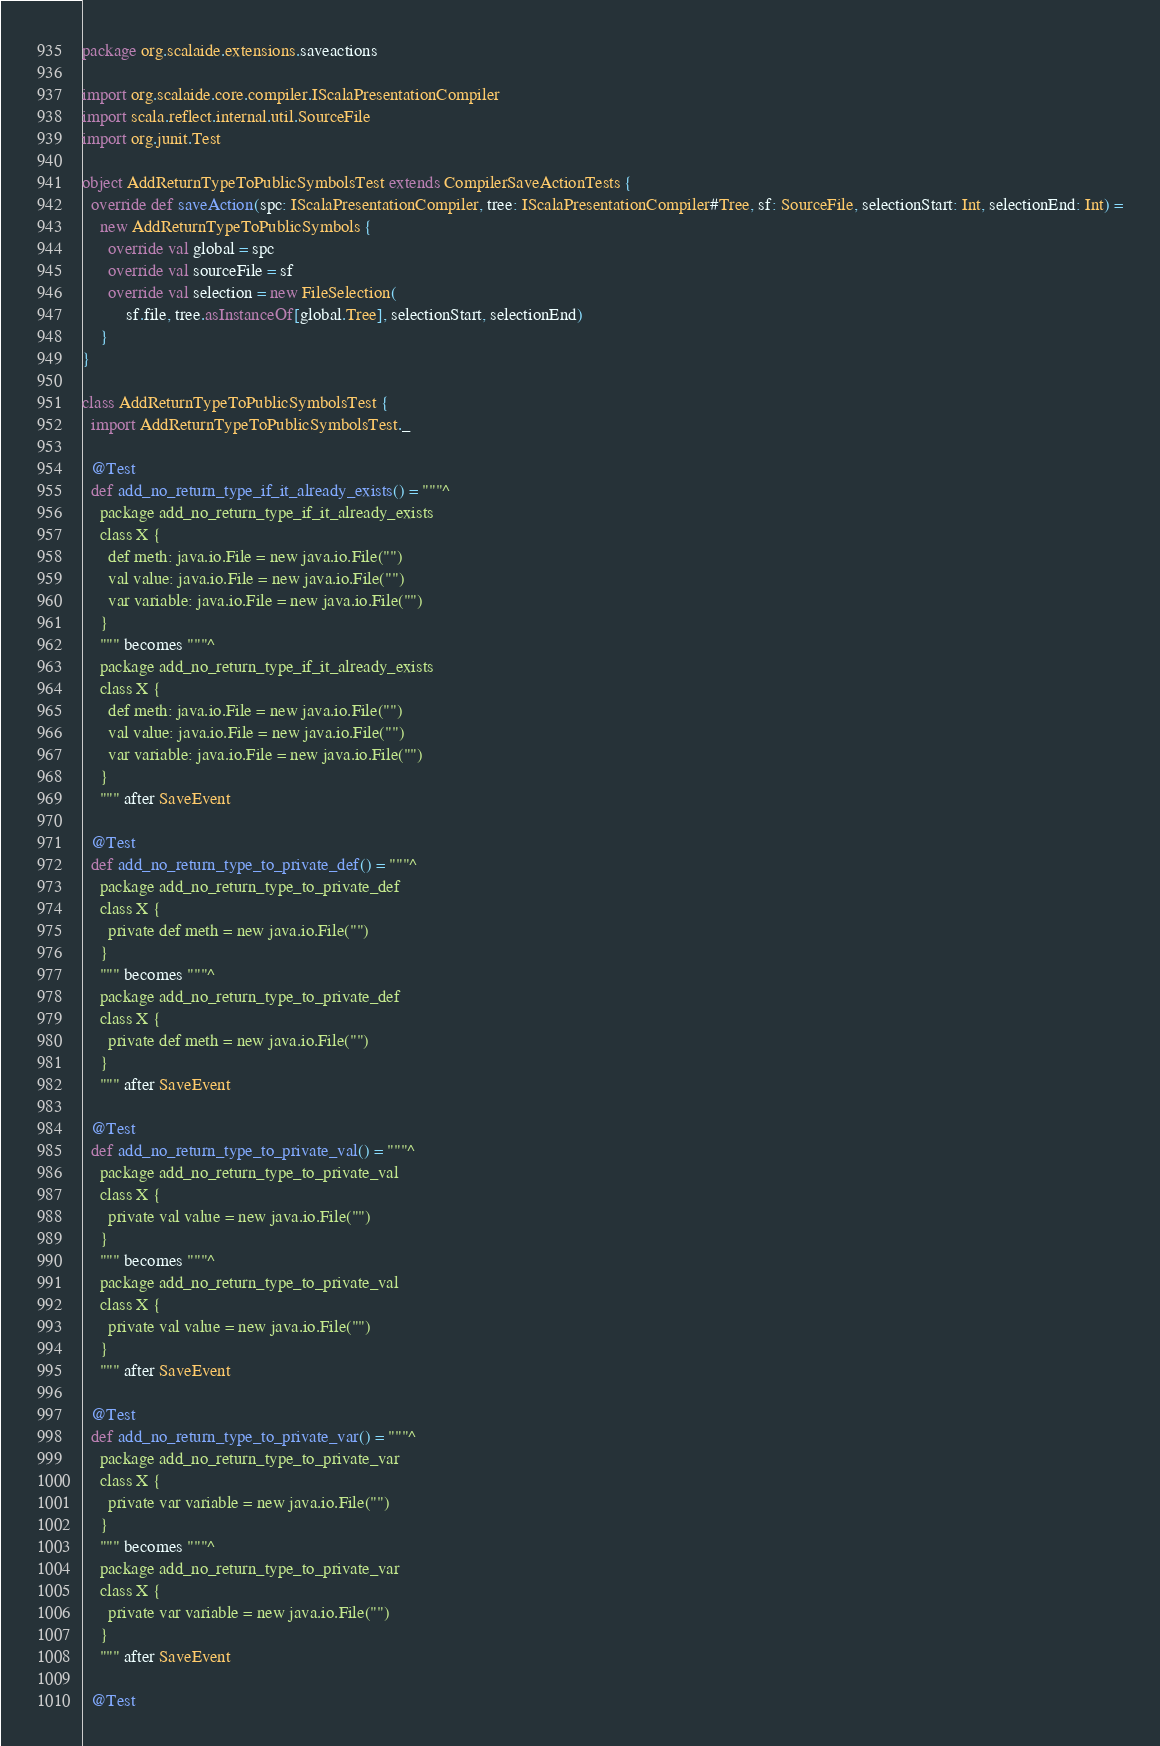Convert code to text. <code><loc_0><loc_0><loc_500><loc_500><_Scala_>package org.scalaide.extensions.saveactions

import org.scalaide.core.compiler.IScalaPresentationCompiler
import scala.reflect.internal.util.SourceFile
import org.junit.Test

object AddReturnTypeToPublicSymbolsTest extends CompilerSaveActionTests {
  override def saveAction(spc: IScalaPresentationCompiler, tree: IScalaPresentationCompiler#Tree, sf: SourceFile, selectionStart: Int, selectionEnd: Int) =
    new AddReturnTypeToPublicSymbols {
      override val global = spc
      override val sourceFile = sf
      override val selection = new FileSelection(
          sf.file, tree.asInstanceOf[global.Tree], selectionStart, selectionEnd)
    }
}

class AddReturnTypeToPublicSymbolsTest {
  import AddReturnTypeToPublicSymbolsTest._

  @Test
  def add_no_return_type_if_it_already_exists() = """^
    package add_no_return_type_if_it_already_exists
    class X {
      def meth: java.io.File = new java.io.File("")
      val value: java.io.File = new java.io.File("")
      var variable: java.io.File = new java.io.File("")
    }
    """ becomes """^
    package add_no_return_type_if_it_already_exists
    class X {
      def meth: java.io.File = new java.io.File("")
      val value: java.io.File = new java.io.File("")
      var variable: java.io.File = new java.io.File("")
    }
    """ after SaveEvent

  @Test
  def add_no_return_type_to_private_def() = """^
    package add_no_return_type_to_private_def
    class X {
      private def meth = new java.io.File("")
    }
    """ becomes """^
    package add_no_return_type_to_private_def
    class X {
      private def meth = new java.io.File("")
    }
    """ after SaveEvent

  @Test
  def add_no_return_type_to_private_val() = """^
    package add_no_return_type_to_private_val
    class X {
      private val value = new java.io.File("")
    }
    """ becomes """^
    package add_no_return_type_to_private_val
    class X {
      private val value = new java.io.File("")
    }
    """ after SaveEvent

  @Test
  def add_no_return_type_to_private_var() = """^
    package add_no_return_type_to_private_var
    class X {
      private var variable = new java.io.File("")
    }
    """ becomes """^
    package add_no_return_type_to_private_var
    class X {
      private var variable = new java.io.File("")
    }
    """ after SaveEvent

  @Test</code> 